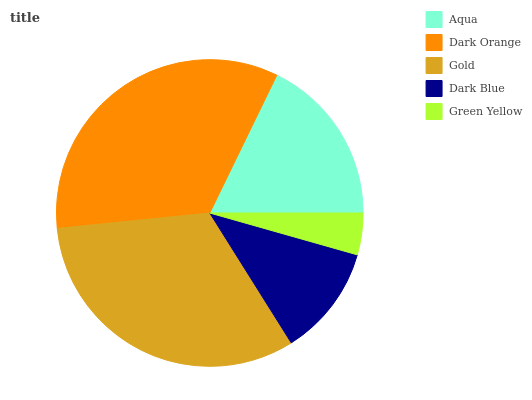Is Green Yellow the minimum?
Answer yes or no. Yes. Is Dark Orange the maximum?
Answer yes or no. Yes. Is Gold the minimum?
Answer yes or no. No. Is Gold the maximum?
Answer yes or no. No. Is Dark Orange greater than Gold?
Answer yes or no. Yes. Is Gold less than Dark Orange?
Answer yes or no. Yes. Is Gold greater than Dark Orange?
Answer yes or no. No. Is Dark Orange less than Gold?
Answer yes or no. No. Is Aqua the high median?
Answer yes or no. Yes. Is Aqua the low median?
Answer yes or no. Yes. Is Green Yellow the high median?
Answer yes or no. No. Is Dark Blue the low median?
Answer yes or no. No. 